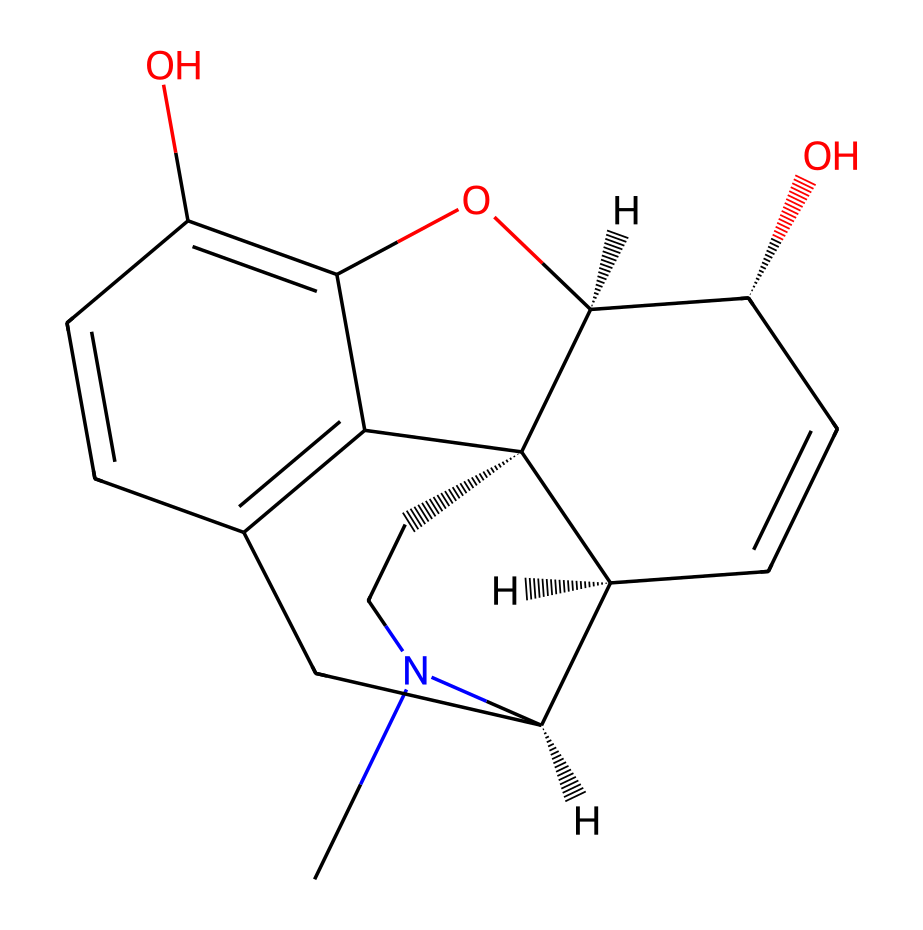What is the molecular formula of morphine? To derive the molecular formula from the SMILES representation, you count each type of atom present. In the given SMILES, the breakdown includes carbon (C), hydrogen (H), nitrogen (N), and oxygen (O) atoms. Summing these yields C17, H19, N1, O3, leading to the formula C17H19NO3.
Answer: C17H19NO3 How many rings are present in the structure of morphine? The SMILES representation indicates the presence of multiple cyclic structures. By examining the notation, you can identify three distinct ring closures (marked by numbers), indicating that morphine has five rings in total.
Answer: five What type of functional groups are present in morphine? Functional groups can be identified by examining the components of the structure. Key groups such as hydroxyl (-OH) and ether (-O-) can be seen in the structure. The presence of these groups indicates that morphine has phenolic and alcoholic characteristics.
Answer: phenolic and alcoholic What is the primary nitrogen type in morphine? The nitrogen atom in the structure is bonded to carbon and hydrogen but does not show any indication of quaternary ammonium (where nitrogen has four bonds). This suggests that it is a tertiary amine.
Answer: tertiary amine How does the unique structure of morphine classify it as an alkaloid? Alkaloids typically have a complex structure with a basic nitrogen atom. In morphine, the nitrogen is part of a ring and contributes to its basic nature, meeting the alkaloid criteria, which includes being derived from plants and exhibiting pronounced physiological effects.
Answer: derived from plants Which part of morphine contributes to its analgesic properties? The molecular structure reveals that the interaction between the nitrogen atom and the aromatic ring systems provides the essential interaction sites for binding to opioid receptors, which is crucial for its pain-relieving effects.
Answer: nitrogen and aromatic rings 